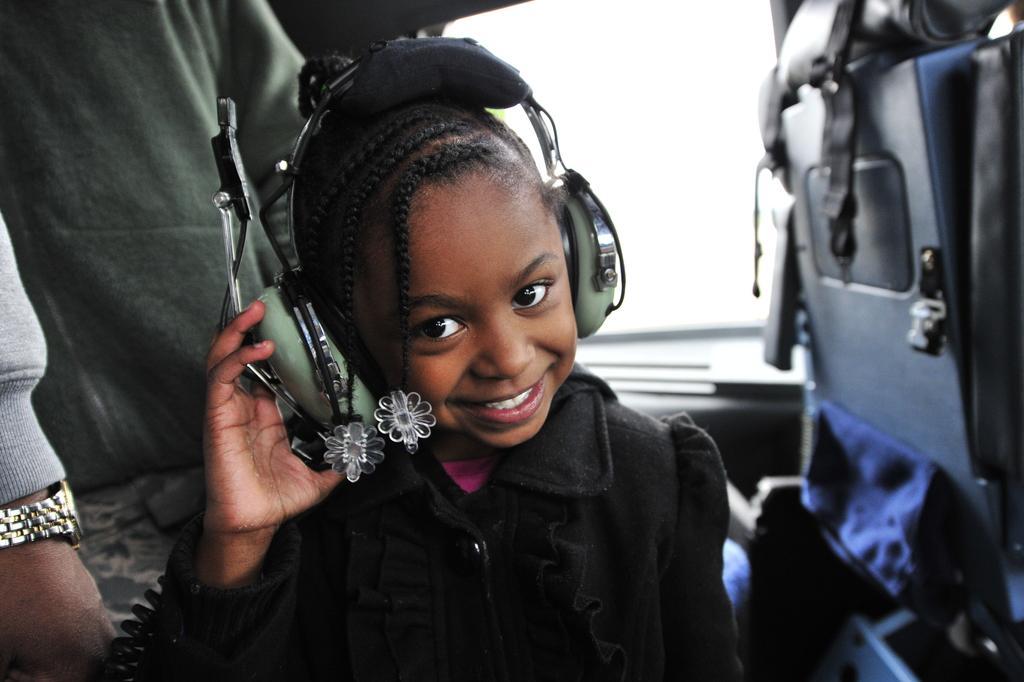Can you describe this image briefly? In this image I can see two persons, chair and a head phone may be in a vehicle and a window. This image is taken may be in a vehicle during a day. 